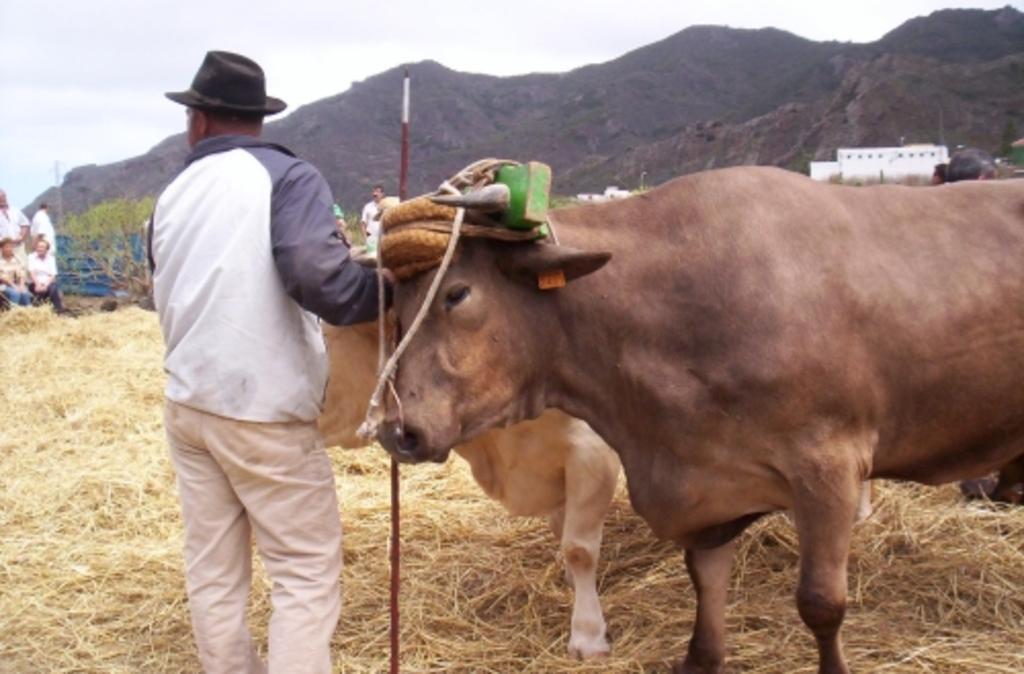Could you give a brief overview of what you see in this image? In the image in the center we can see two cow and one person standing and holding stick and he is wearing hat. And on cows,we can see rope and few other objects. In the background we can see sky,clouds,hill,fence,building,wall,trees,grass,two persons were sitting and few people were standing. 